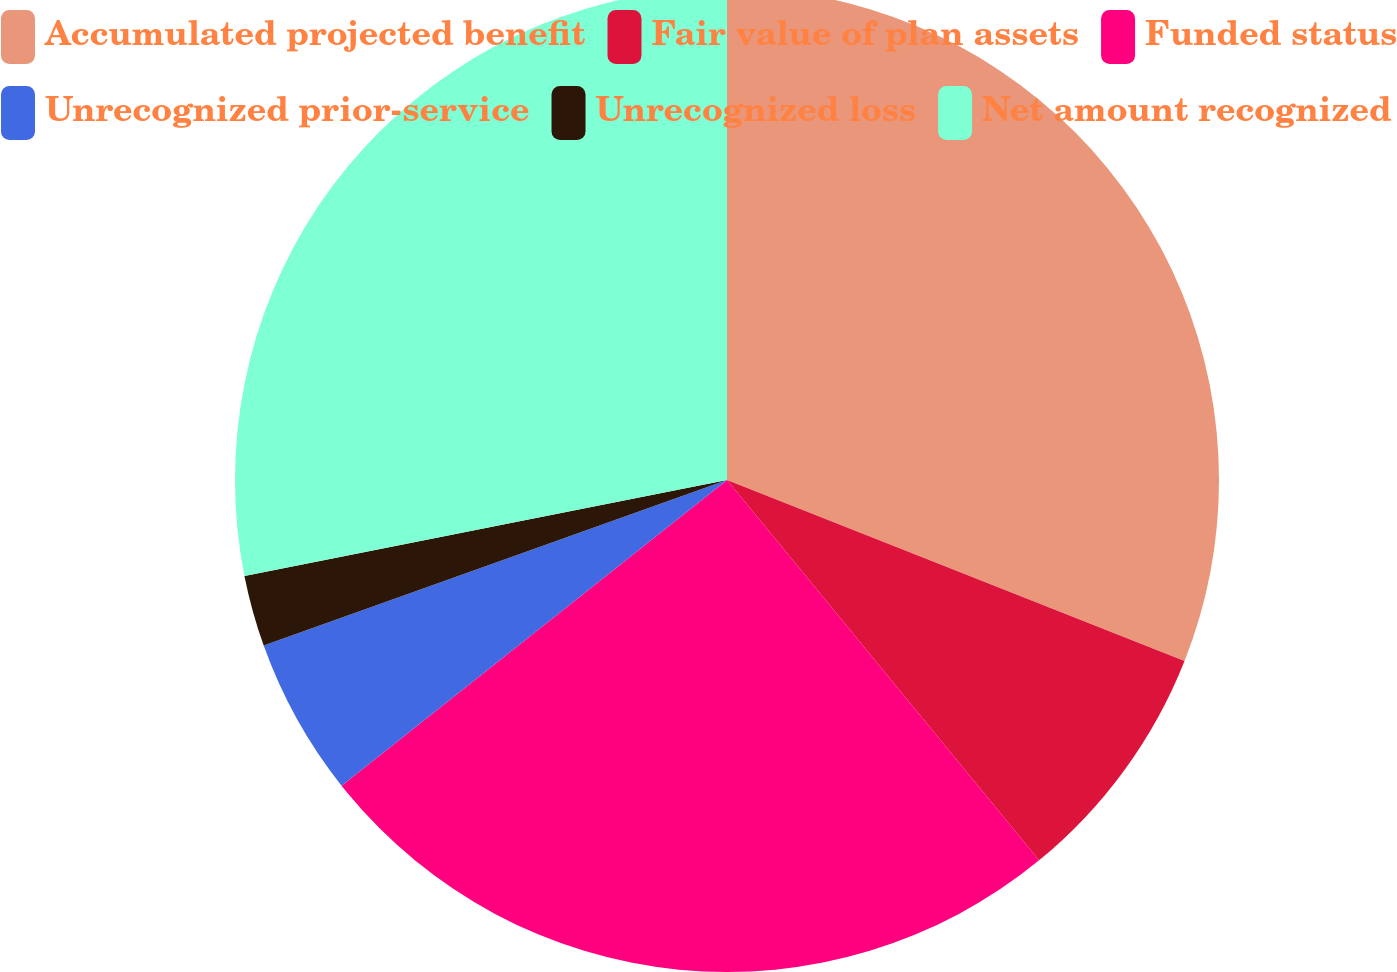Convert chart. <chart><loc_0><loc_0><loc_500><loc_500><pie_chart><fcel>Accumulated projected benefit<fcel>Fair value of plan assets<fcel>Funded status<fcel>Unrecognized prior-service<fcel>Unrecognized loss<fcel>Net amount recognized<nl><fcel>30.99%<fcel>8.07%<fcel>25.26%<fcel>5.21%<fcel>2.34%<fcel>28.12%<nl></chart> 